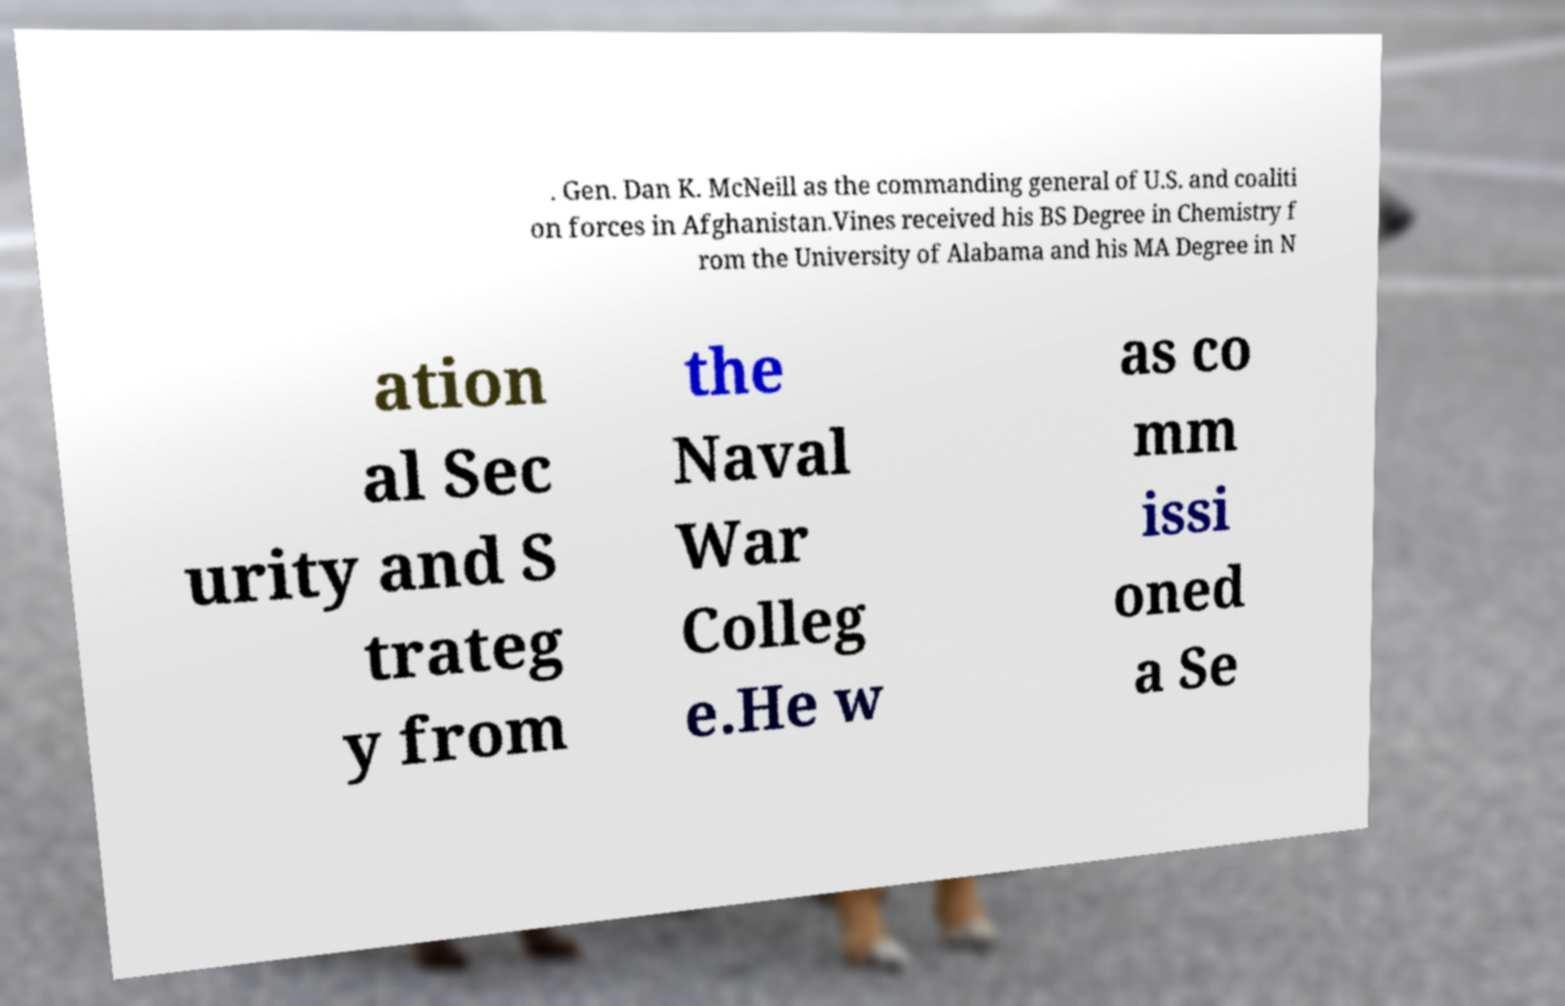What messages or text are displayed in this image? I need them in a readable, typed format. . Gen. Dan K. McNeill as the commanding general of U.S. and coaliti on forces in Afghanistan.Vines received his BS Degree in Chemistry f rom the University of Alabama and his MA Degree in N ation al Sec urity and S trateg y from the Naval War Colleg e.He w as co mm issi oned a Se 